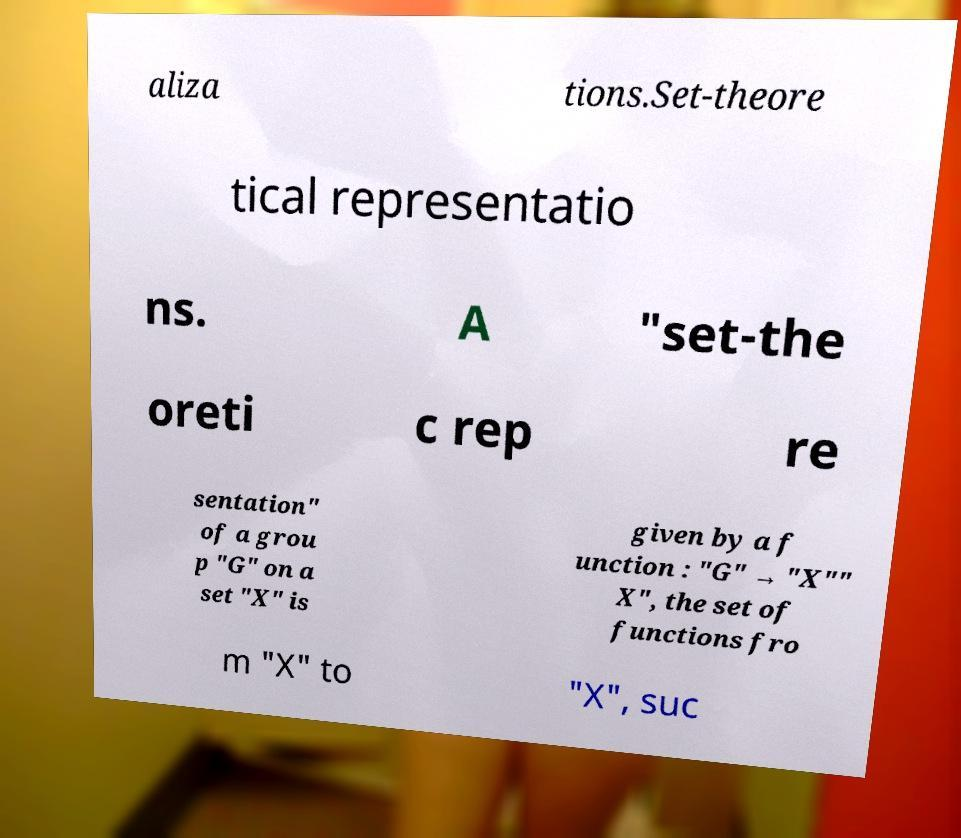I need the written content from this picture converted into text. Can you do that? aliza tions.Set-theore tical representatio ns. A "set-the oreti c rep re sentation" of a grou p "G" on a set "X" is given by a f unction : "G" → "X"" X", the set of functions fro m "X" to "X", suc 